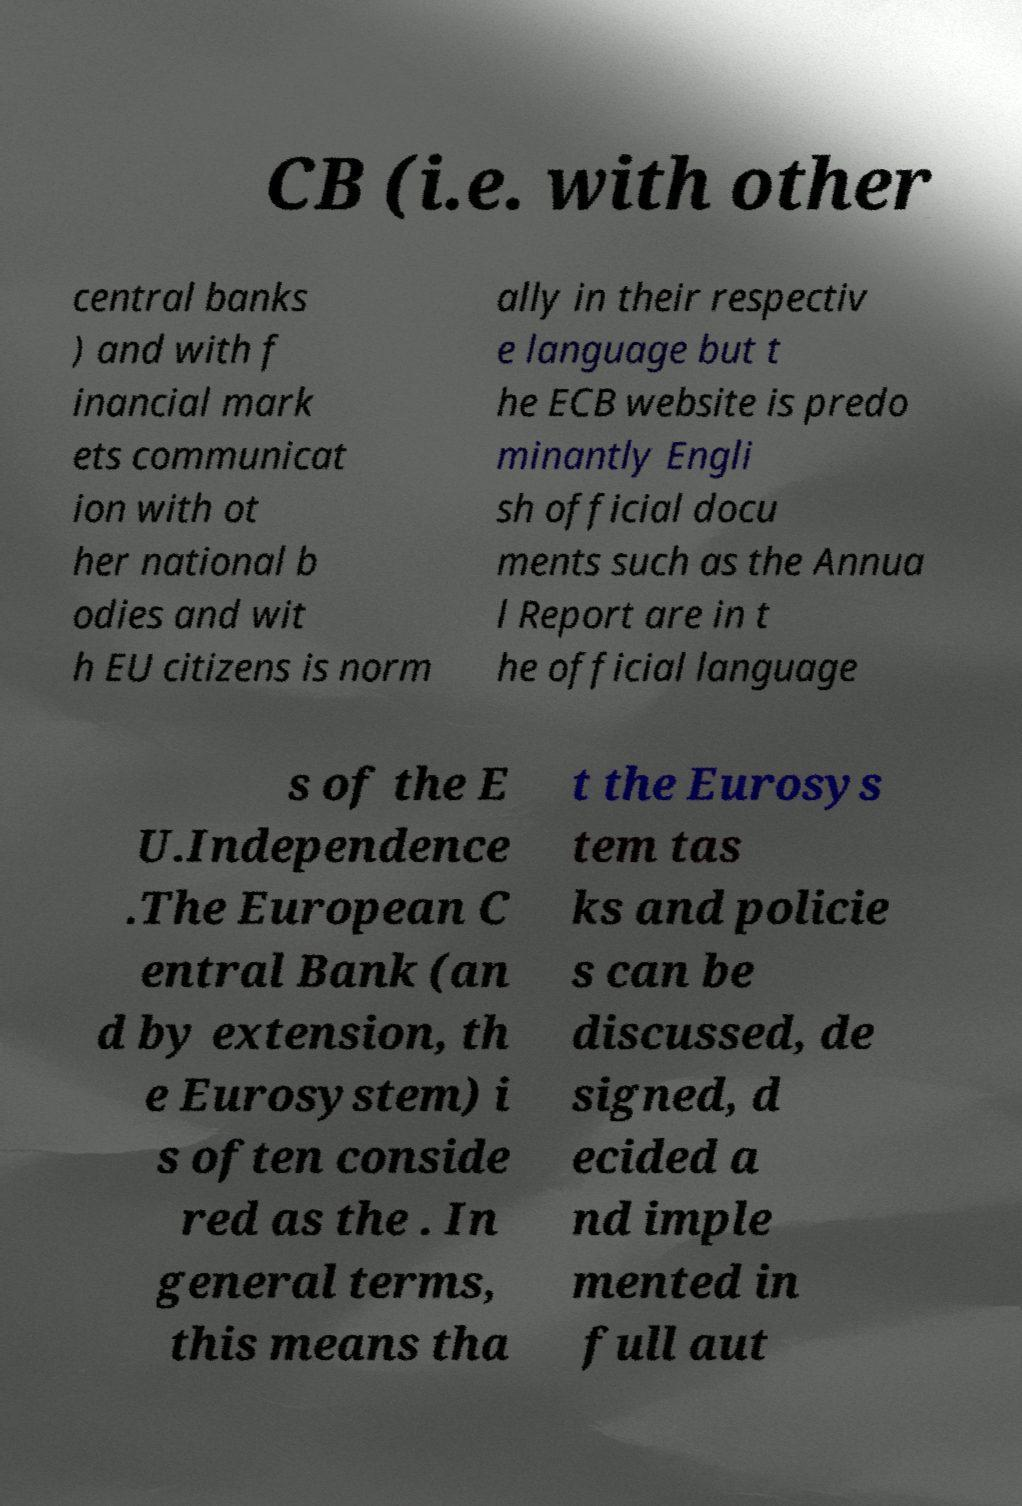Please identify and transcribe the text found in this image. CB (i.e. with other central banks ) and with f inancial mark ets communicat ion with ot her national b odies and wit h EU citizens is norm ally in their respectiv e language but t he ECB website is predo minantly Engli sh official docu ments such as the Annua l Report are in t he official language s of the E U.Independence .The European C entral Bank (an d by extension, th e Eurosystem) i s often conside red as the . In general terms, this means tha t the Eurosys tem tas ks and policie s can be discussed, de signed, d ecided a nd imple mented in full aut 